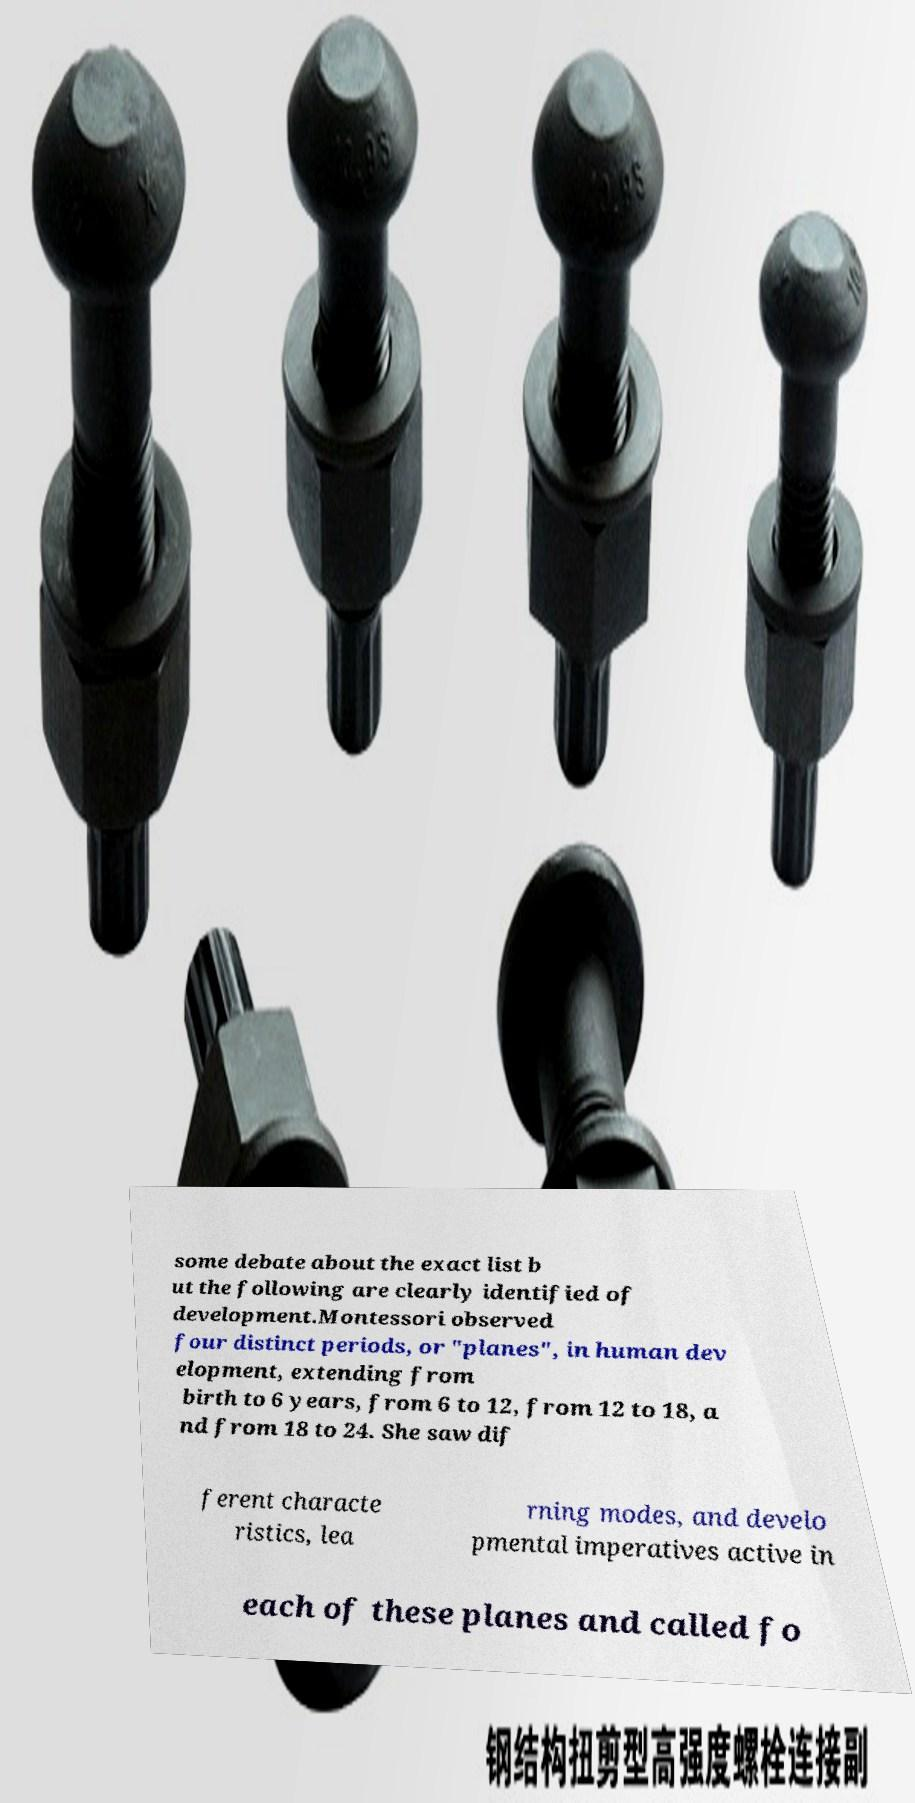There's text embedded in this image that I need extracted. Can you transcribe it verbatim? some debate about the exact list b ut the following are clearly identified of development.Montessori observed four distinct periods, or "planes", in human dev elopment, extending from birth to 6 years, from 6 to 12, from 12 to 18, a nd from 18 to 24. She saw dif ferent characte ristics, lea rning modes, and develo pmental imperatives active in each of these planes and called fo 